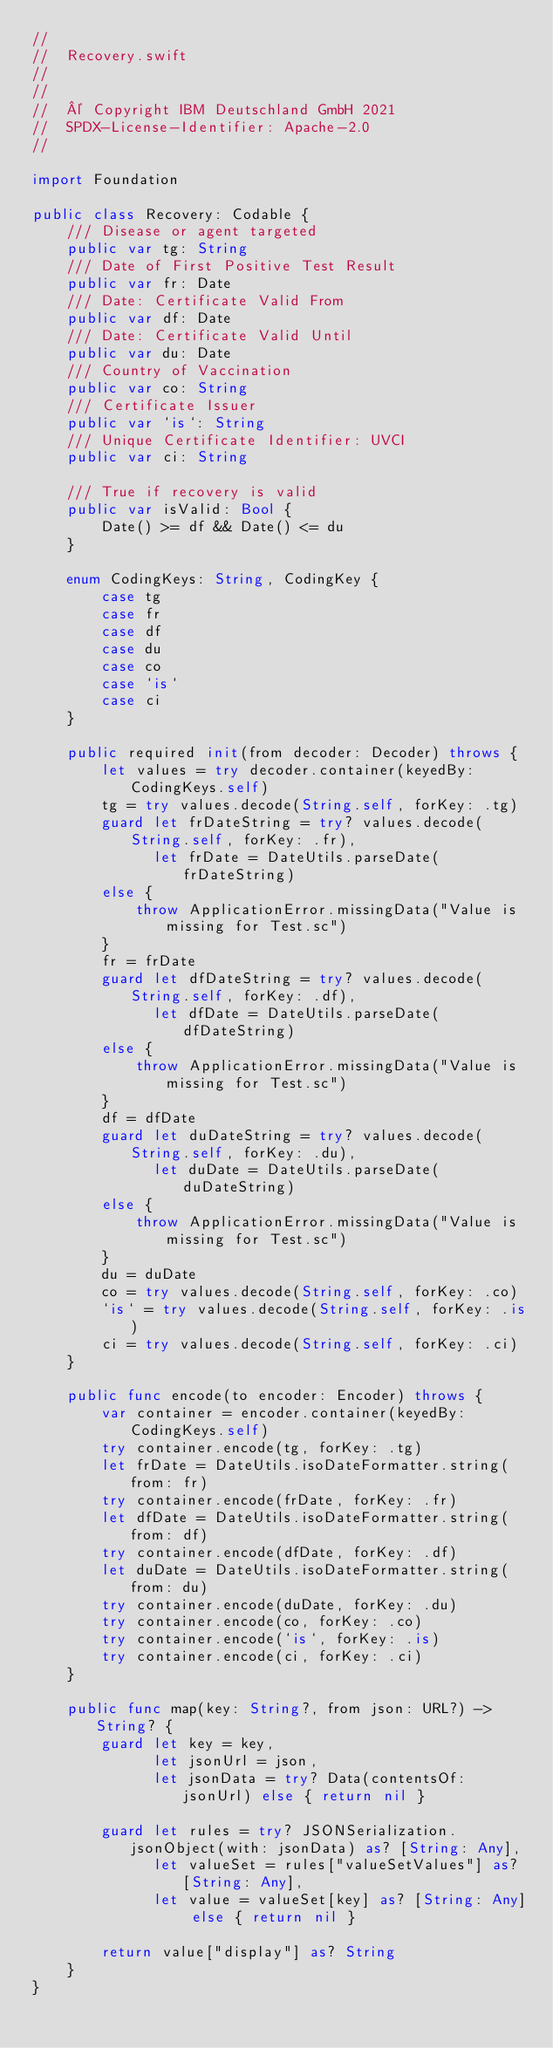Convert code to text. <code><loc_0><loc_0><loc_500><loc_500><_Swift_>//
//  Recovery.swift
//
//
//  © Copyright IBM Deutschland GmbH 2021
//  SPDX-License-Identifier: Apache-2.0
//

import Foundation

public class Recovery: Codable {
    /// Disease or agent targeted
    public var tg: String
    /// Date of First Positive Test Result
    public var fr: Date
    /// Date: Certificate Valid From
    public var df: Date
    /// Date: Certificate Valid Until
    public var du: Date
    /// Country of Vaccination
    public var co: String
    /// Certificate Issuer
    public var `is`: String
    /// Unique Certificate Identifier: UVCI
    public var ci: String

    /// True if recovery is valid
    public var isValid: Bool {
        Date() >= df && Date() <= du
    }

    enum CodingKeys: String, CodingKey {
        case tg
        case fr
        case df
        case du
        case co
        case `is`
        case ci
    }

    public required init(from decoder: Decoder) throws {
        let values = try decoder.container(keyedBy: CodingKeys.self)
        tg = try values.decode(String.self, forKey: .tg)
        guard let frDateString = try? values.decode(String.self, forKey: .fr),
              let frDate = DateUtils.parseDate(frDateString)
        else {
            throw ApplicationError.missingData("Value is missing for Test.sc")
        }
        fr = frDate
        guard let dfDateString = try? values.decode(String.self, forKey: .df),
              let dfDate = DateUtils.parseDate(dfDateString)
        else {
            throw ApplicationError.missingData("Value is missing for Test.sc")
        }
        df = dfDate
        guard let duDateString = try? values.decode(String.self, forKey: .du),
              let duDate = DateUtils.parseDate(duDateString)
        else {
            throw ApplicationError.missingData("Value is missing for Test.sc")
        }
        du = duDate
        co = try values.decode(String.self, forKey: .co)
        `is` = try values.decode(String.self, forKey: .is)
        ci = try values.decode(String.self, forKey: .ci)
    }

    public func encode(to encoder: Encoder) throws {
        var container = encoder.container(keyedBy: CodingKeys.self)
        try container.encode(tg, forKey: .tg)
        let frDate = DateUtils.isoDateFormatter.string(from: fr)
        try container.encode(frDate, forKey: .fr)
        let dfDate = DateUtils.isoDateFormatter.string(from: df)
        try container.encode(dfDate, forKey: .df)
        let duDate = DateUtils.isoDateFormatter.string(from: du)
        try container.encode(duDate, forKey: .du)
        try container.encode(co, forKey: .co)
        try container.encode(`is`, forKey: .is)
        try container.encode(ci, forKey: .ci)
    }

    public func map(key: String?, from json: URL?) -> String? {
        guard let key = key,
              let jsonUrl = json,
              let jsonData = try? Data(contentsOf: jsonUrl) else { return nil }

        guard let rules = try? JSONSerialization.jsonObject(with: jsonData) as? [String: Any],
              let valueSet = rules["valueSetValues"] as? [String: Any],
              let value = valueSet[key] as? [String: Any] else { return nil }

        return value["display"] as? String
    }
}
</code> 